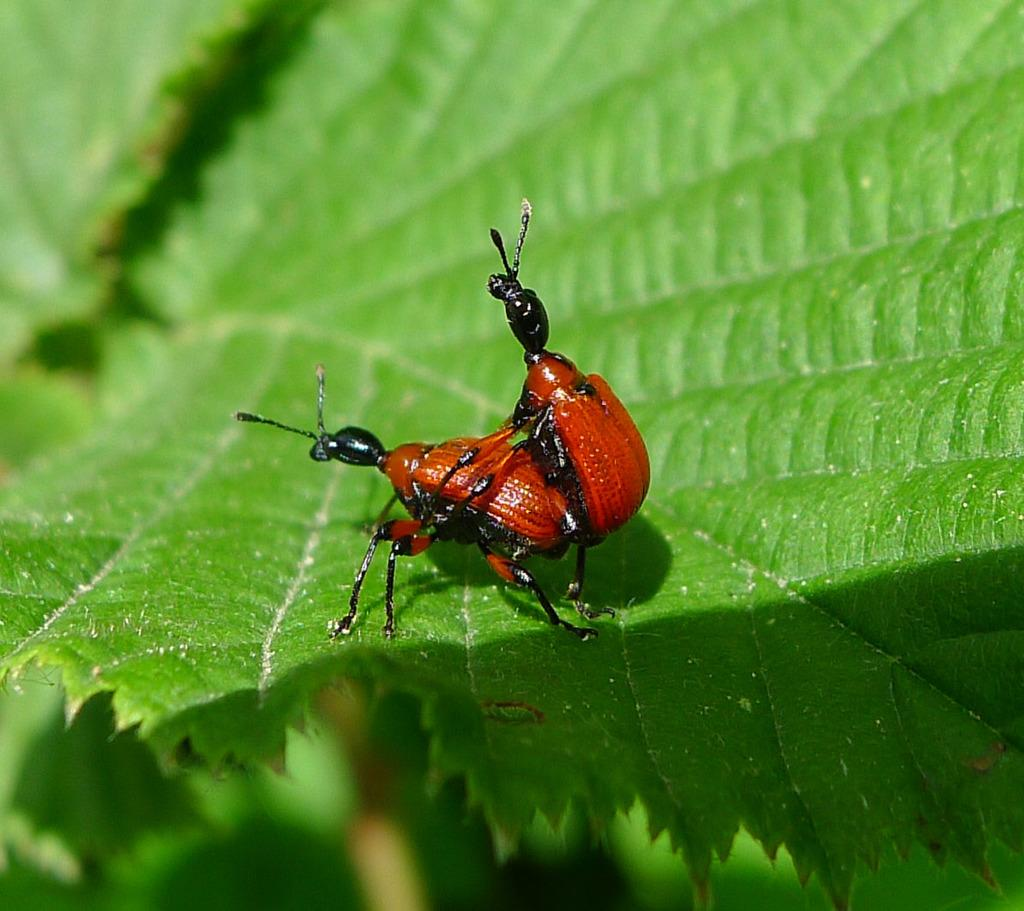How many insects are present in the image? There are two insects in the image. Where are the insects located? The insects are on a leaf. What type of wire is being used by the insects to balance themselves in the image? There is no wire present in the image, and the insects are not balancing themselves. 